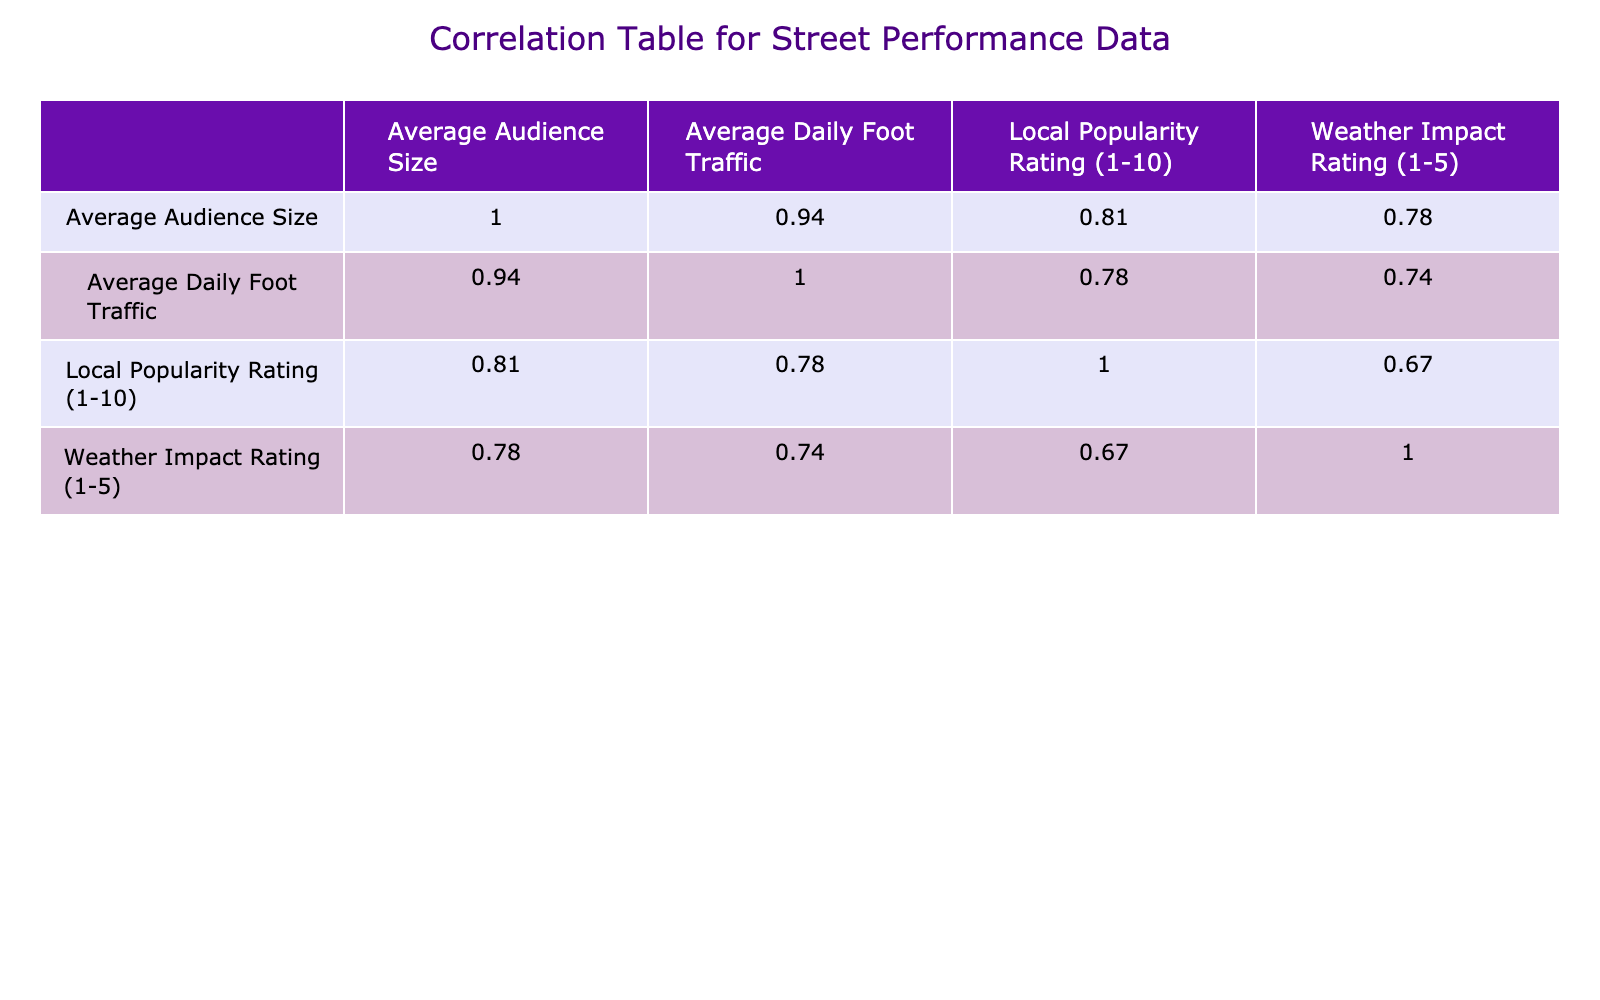What is the average audience size at Shibuya Crossing? The audience size for Shibuya Crossing is listed directly in the table as 400.
Answer: 400 Which location has the highest local popularity rating? The local popularity ratings for each location are compared, and Times Square has the highest rating of 10.
Answer: Times Square What is the average daily foot traffic at Nashville Broadway? The average daily foot traffic for Nashville Broadway is provided in the table as 25000.
Answer: 25000 Is the average audience size at The Royal Mile greater than at Pike Place Market? The average audience size at The Royal Mile is 250, while at Pike Place Market it's 180. Since 250 is greater than 180, the statement is true.
Answer: Yes What is the difference in average daily foot traffic between Shibuya Crossing and Southbank? The foot traffic for Shibuya Crossing is 30000, and for Southbank, it is 7000. To find the difference, subtract Southbank's foot traffic from Shibuya Crossing's: 30000 - 7000 = 23000.
Answer: 23000 Which locations have an average audience size less than 200? By inspecting the audience sizes from the table, the locations with less than 200 are Central Park (150), Venice Beach (200, which does not count), and La Rambla (160). Therefore, only Central Park and La Rambla meet this criterion.
Answer: Central Park, La Rambla What is the average local popularity rating across all locations? To find the average, sum the local popularity ratings (9 + 10 + 8 + 9 + 8 + 10 + 9 + 7 + 10 + 8 = 88) and divide by the number of locations (10). This gives us 88/10 = 8.8.
Answer: 8.8 Does higher weather impact correlate with a larger average audience size? To assess correlation, we look at the weather impact ratings and the audience sizes. Shibuya Crossing is rated 5 for weather impact and has the highest audience; Times Square, rated 4, also has a large audience of 300. This trend seems to indicate that higher weather impact ratings are associated with larger audiences.
Answer: Yes Which location has the lowest audience size in relation to its foot traffic? The audience sizes relative to foot traffic would be calculated by dividing the average audience size by the average daily foot traffic for each location. When calculated, Southbank has an audience size of 170 with a foot traffic of 7000, yielding a ratio of approximately 0.024 which is lower than all others.
Answer: Southbank 